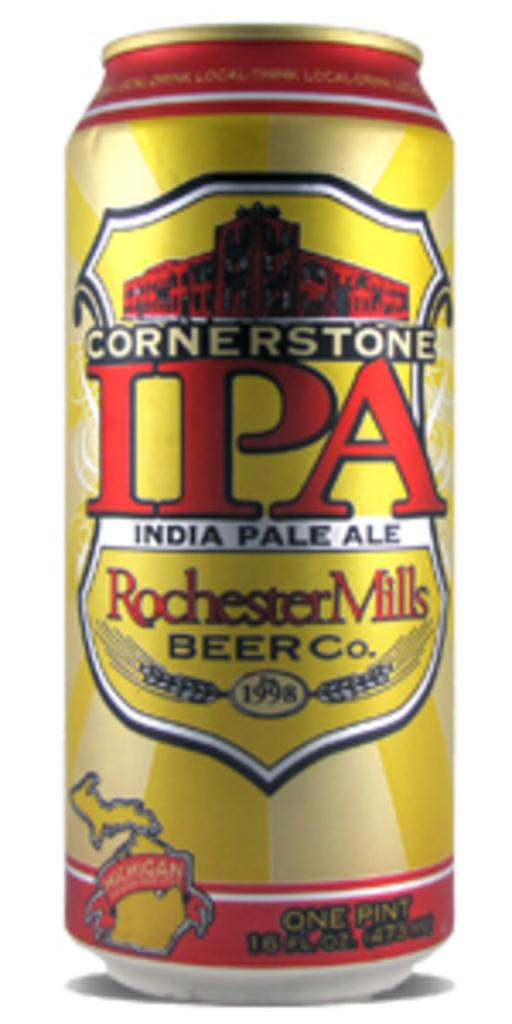<image>
Give a short and clear explanation of the subsequent image. the letters IPA that is on a can 